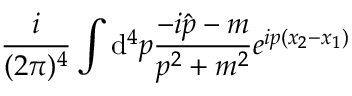<formula> <loc_0><loc_0><loc_500><loc_500>\frac { i } { ( 2 \pi ) ^ { 4 } } \int { \mathrm d } ^ { 4 } p \frac { - i \hat { p } - m } { p ^ { 2 } + m ^ { 2 } } e ^ { i p ( x _ { 2 } - x _ { 1 } ) }</formula> 